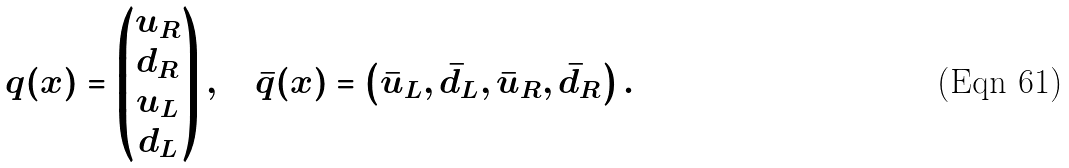<formula> <loc_0><loc_0><loc_500><loc_500>q ( x ) = \left ( \begin{matrix} u _ { R } \\ d _ { R } \\ u _ { L } \\ d _ { L } \end{matrix} \right ) , \quad \bar { q } ( x ) = \left ( \begin{matrix} \bar { u } _ { L } , \bar { d } _ { L } , \bar { u } _ { R } , \bar { d } _ { R } \end{matrix} \right ) .</formula> 